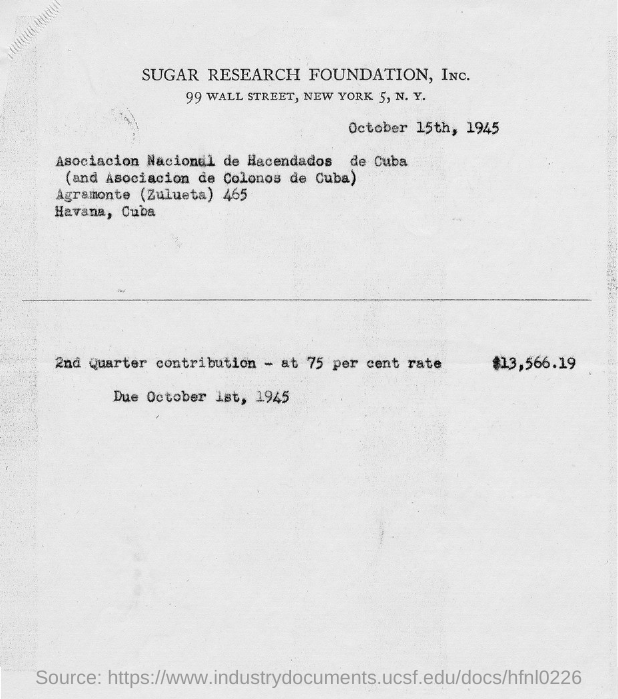When is the document dated?
Make the answer very short. October 15th, 1945. What is the due date?
Provide a short and direct response. October 1st, 1945. 